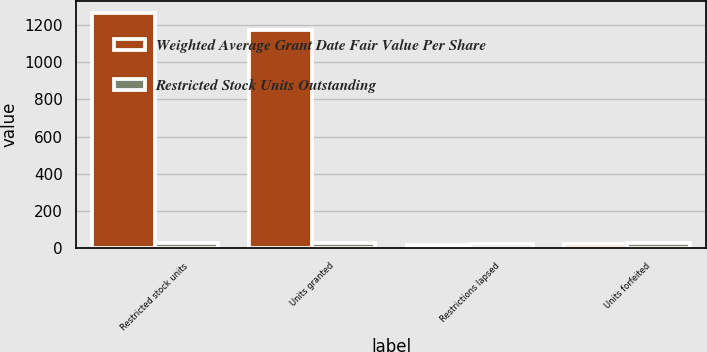Convert chart. <chart><loc_0><loc_0><loc_500><loc_500><stacked_bar_chart><ecel><fcel>Restricted stock units<fcel>Units granted<fcel>Restrictions lapsed<fcel>Units forfeited<nl><fcel>Weighted Average Grant Date Fair Value Per Share<fcel>1265<fcel>1171<fcel>19<fcel>22<nl><fcel>Restricted Stock Units Outstanding<fcel>28.21<fcel>28.86<fcel>24.7<fcel>29.1<nl></chart> 